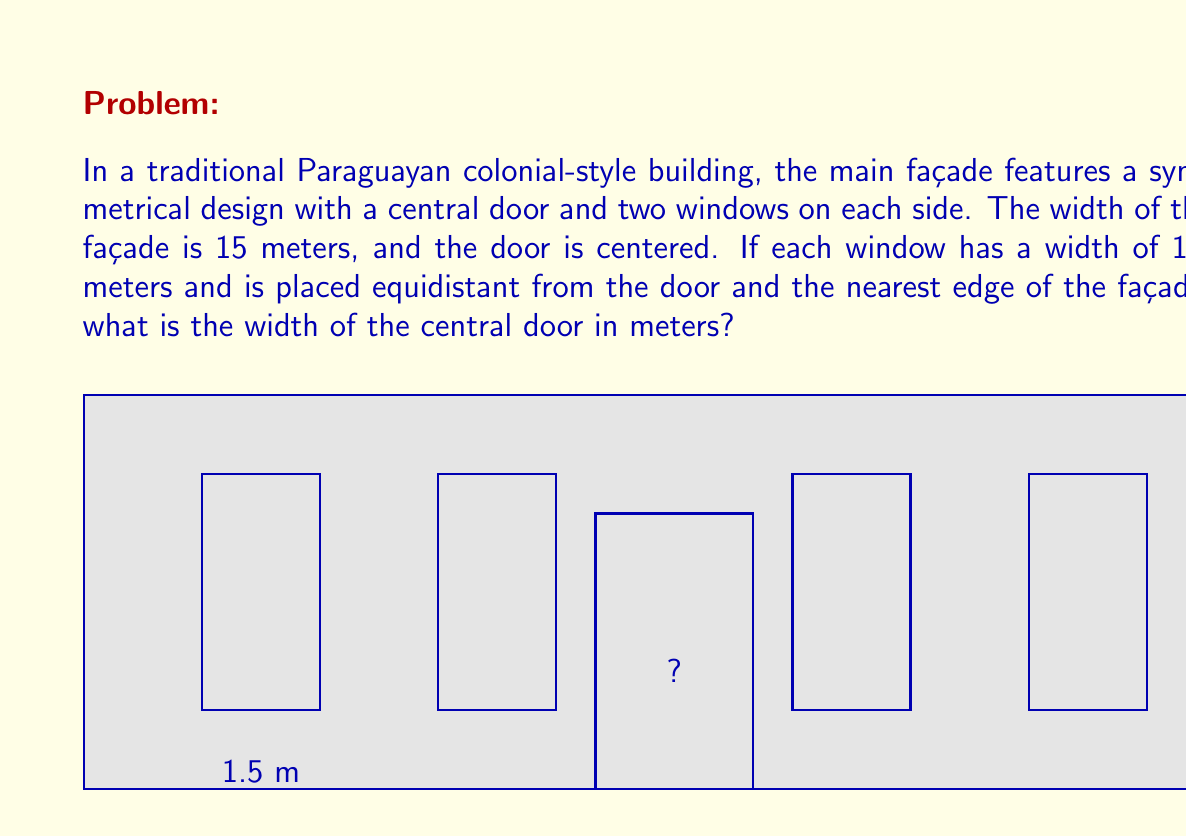What is the answer to this math problem? Let's approach this step-by-step:

1) First, let's define some variables:
   Let $x$ be the width of the door
   Let $y$ be the distance from the edge of the façade to the nearest window

2) We know that the total width of the façade is 15 meters. We can express this as an equation:
   $$2y + 2(1.5) + 2(1.5) + x = 15$$
   
   This equation represents: left gap + left windows + right windows + right gap + door width = total width

3) Simplify the equation:
   $$2y + 3 + 3 + x = 15$$
   $$2y + x = 9$$

4) Due to the symmetry of the design, we know that $y$ is equal on both sides. We can express this as:
   $$y = \frac{15 - x - 3}{2} = 6 - \frac{x}{2}$$

5) Substitute this expression for $y$ into our equation from step 3:
   $$2(6 - \frac{x}{2}) + x = 9$$

6) Solve for $x$:
   $$12 - x + x = 9$$
   $$12 = 9$$
   $$x = 3$$

Therefore, the width of the central door is 3 meters.
Answer: 3 meters 